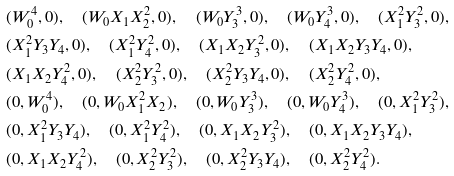Convert formula to latex. <formula><loc_0><loc_0><loc_500><loc_500>& ( W _ { 0 } ^ { 4 } , 0 ) , \quad ( W _ { 0 } X _ { 1 } X _ { 2 } ^ { 2 } , 0 ) , \quad ( W _ { 0 } Y _ { 3 } ^ { 3 } , 0 ) , \quad ( W _ { 0 } Y _ { 4 } ^ { 3 } , 0 ) , \quad ( X _ { 1 } ^ { 2 } Y _ { 3 } ^ { 2 } , 0 ) , & \\ & ( X _ { 1 } ^ { 2 } Y _ { 3 } Y _ { 4 } , 0 ) , \quad ( X _ { 1 } ^ { 2 } Y _ { 4 } ^ { 2 } , 0 ) , \quad ( X _ { 1 } X _ { 2 } Y _ { 3 } ^ { 2 } , 0 ) , \quad ( X _ { 1 } X _ { 2 } Y _ { 3 } Y _ { 4 } , 0 ) , & \\ & ( X _ { 1 } X _ { 2 } Y _ { 4 } ^ { 2 } , 0 ) , \quad ( X _ { 2 } ^ { 2 } Y _ { 3 } ^ { 2 } , 0 ) , \quad ( X _ { 2 } ^ { 2 } Y _ { 3 } Y _ { 4 } , 0 ) , \quad ( X _ { 2 } ^ { 2 } Y _ { 4 } ^ { 2 } , 0 ) , & \\ & ( 0 , W _ { 0 } ^ { 4 } ) , \quad ( 0 , W _ { 0 } X _ { 1 } ^ { 2 } X _ { 2 } ) , \quad ( 0 , W _ { 0 } Y _ { 3 } ^ { 3 } ) , \quad ( 0 , W _ { 0 } Y _ { 4 } ^ { 3 } ) , \quad ( 0 , X _ { 1 } ^ { 2 } Y _ { 3 } ^ { 2 } ) , & \\ & ( 0 , X _ { 1 } ^ { 2 } Y _ { 3 } Y _ { 4 } ) , \quad ( 0 , X _ { 1 } ^ { 2 } Y _ { 4 } ^ { 2 } ) , \quad ( 0 , X _ { 1 } X _ { 2 } Y _ { 3 } ^ { 2 } ) , \quad ( 0 , X _ { 1 } X _ { 2 } Y _ { 3 } Y _ { 4 } ) , & \\ & ( 0 , X _ { 1 } X _ { 2 } Y _ { 4 } ^ { 2 } ) , \quad ( 0 , X _ { 2 } ^ { 2 } Y _ { 3 } ^ { 2 } ) , \quad ( 0 , X _ { 2 } ^ { 2 } Y _ { 3 } Y _ { 4 } ) , \quad ( 0 , X _ { 2 } ^ { 2 } Y _ { 4 } ^ { 2 } ) . &</formula> 